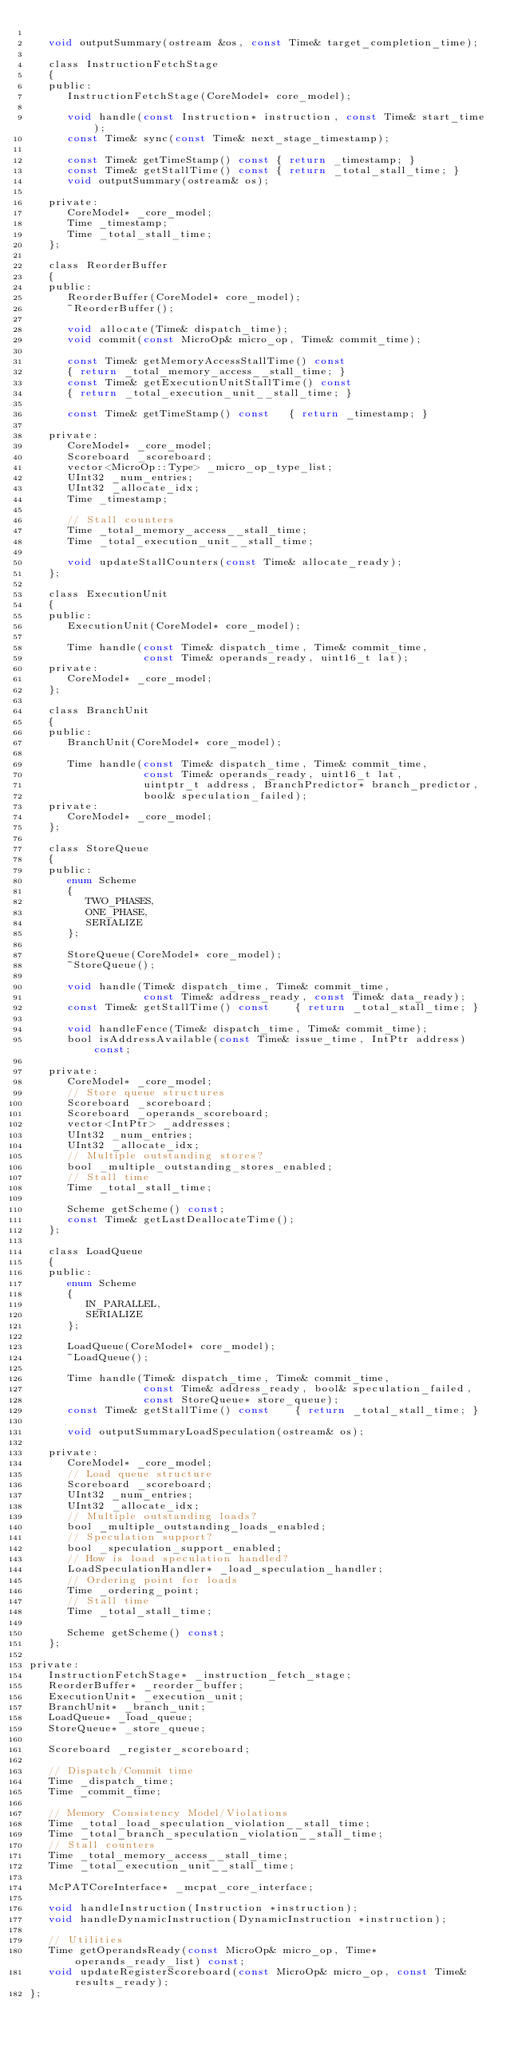<code> <loc_0><loc_0><loc_500><loc_500><_C_>
   void outputSummary(ostream &os, const Time& target_completion_time);

   class InstructionFetchStage
   {
   public:
      InstructionFetchStage(CoreModel* core_model);

      void handle(const Instruction* instruction, const Time& start_time);
      const Time& sync(const Time& next_stage_timestamp);

      const Time& getTimeStamp() const { return _timestamp; }
      const Time& getStallTime() const { return _total_stall_time; }
      void outputSummary(ostream& os);

   private:
      CoreModel* _core_model;
      Time _timestamp;
      Time _total_stall_time;
   };

   class ReorderBuffer
   {
   public:
      ReorderBuffer(CoreModel* core_model);
      ~ReorderBuffer();

      void allocate(Time& dispatch_time);
      void commit(const MicroOp& micro_op, Time& commit_time);

      const Time& getMemoryAccessStallTime() const
      { return _total_memory_access__stall_time; }
      const Time& getExecutionUnitStallTime() const
      { return _total_execution_unit__stall_time; }
      
      const Time& getTimeStamp() const   { return _timestamp; }

   private:
      CoreModel* _core_model;
      Scoreboard _scoreboard;
      vector<MicroOp::Type> _micro_op_type_list;
      UInt32 _num_entries;
      UInt32 _allocate_idx;
      Time _timestamp;

      // Stall counters
      Time _total_memory_access__stall_time;
      Time _total_execution_unit__stall_time;

      void updateStallCounters(const Time& allocate_ready);
   };

   class ExecutionUnit
   {
   public:
      ExecutionUnit(CoreModel* core_model);

      Time handle(const Time& dispatch_time, Time& commit_time,
                  const Time& operands_ready, uint16_t lat);
   private:
      CoreModel* _core_model;
   };

   class BranchUnit
   {
   public:
      BranchUnit(CoreModel* core_model);

      Time handle(const Time& dispatch_time, Time& commit_time,
                  const Time& operands_ready, uint16_t lat,
                  uintptr_t address, BranchPredictor* branch_predictor,
                  bool& speculation_failed);
   private:
      CoreModel* _core_model;
   };

   class StoreQueue
   {
   public:
      enum Scheme
      {
         TWO_PHASES,
         ONE_PHASE,
         SERIALIZE
      };

      StoreQueue(CoreModel* core_model);
      ~StoreQueue();

      void handle(Time& dispatch_time, Time& commit_time,
                  const Time& address_ready, const Time& data_ready);
      const Time& getStallTime() const    { return _total_stall_time; }
      
      void handleFence(Time& dispatch_time, Time& commit_time);
      bool isAddressAvailable(const Time& issue_time, IntPtr address) const;

   private:
      CoreModel* _core_model;
      // Store queue structures
      Scoreboard _scoreboard;
      Scoreboard _operands_scoreboard;
      vector<IntPtr> _addresses;
      UInt32 _num_entries;
      UInt32 _allocate_idx;
      // Multiple outstanding stores?
      bool _multiple_outstanding_stores_enabled;
      // Stall time
      Time _total_stall_time;
      
      Scheme getScheme() const;
      const Time& getLastDeallocateTime();
   };

   class LoadQueue
   {
   public:
      enum Scheme
      {
         IN_PARALLEL,
         SERIALIZE
      };

      LoadQueue(CoreModel* core_model);
      ~LoadQueue();

      Time handle(Time& dispatch_time, Time& commit_time,
                  const Time& address_ready, bool& speculation_failed,
                  const StoreQueue* store_queue);
      const Time& getStallTime() const    { return _total_stall_time; }

      void outputSummaryLoadSpeculation(ostream& os);

   private:
      CoreModel* _core_model;
      // Load queue structure
      Scoreboard _scoreboard;
      UInt32 _num_entries;
      UInt32 _allocate_idx;
      // Multiple outstanding loads?
      bool _multiple_outstanding_loads_enabled;
      // Speculation support?
      bool _speculation_support_enabled;
      // How is load speculation handled?
      LoadSpeculationHandler* _load_speculation_handler;
      // Ordering point for loads
      Time _ordering_point;
      // Stall time
      Time _total_stall_time;

      Scheme getScheme() const;
   };

private:
   InstructionFetchStage* _instruction_fetch_stage;
   ReorderBuffer* _reorder_buffer;
   ExecutionUnit* _execution_unit;
   BranchUnit* _branch_unit;
   LoadQueue* _load_queue;
   StoreQueue* _store_queue;
   
   Scoreboard _register_scoreboard;

   // Dispatch/Commit time
   Time _dispatch_time;
   Time _commit_time;

   // Memory Consistency Model/Violations
   Time _total_load_speculation_violation__stall_time;
   Time _total_branch_speculation_violation__stall_time;
   // Stall counters
   Time _total_memory_access__stall_time;
   Time _total_execution_unit__stall_time;

   McPATCoreInterface* _mcpat_core_interface;
   
   void handleInstruction(Instruction *instruction);
   void handleDynamicInstruction(DynamicInstruction *instruction);
   
   // Utilities
   Time getOperandsReady(const MicroOp& micro_op, Time* operands_ready_list) const;
   void updateRegisterScoreboard(const MicroOp& micro_op, const Time& results_ready);
};
</code> 